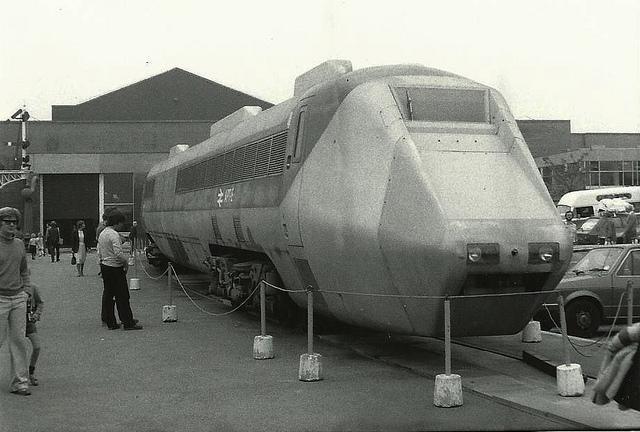How many people are in the picture?
Give a very brief answer. 2. How many birds are in the air?
Give a very brief answer. 0. 